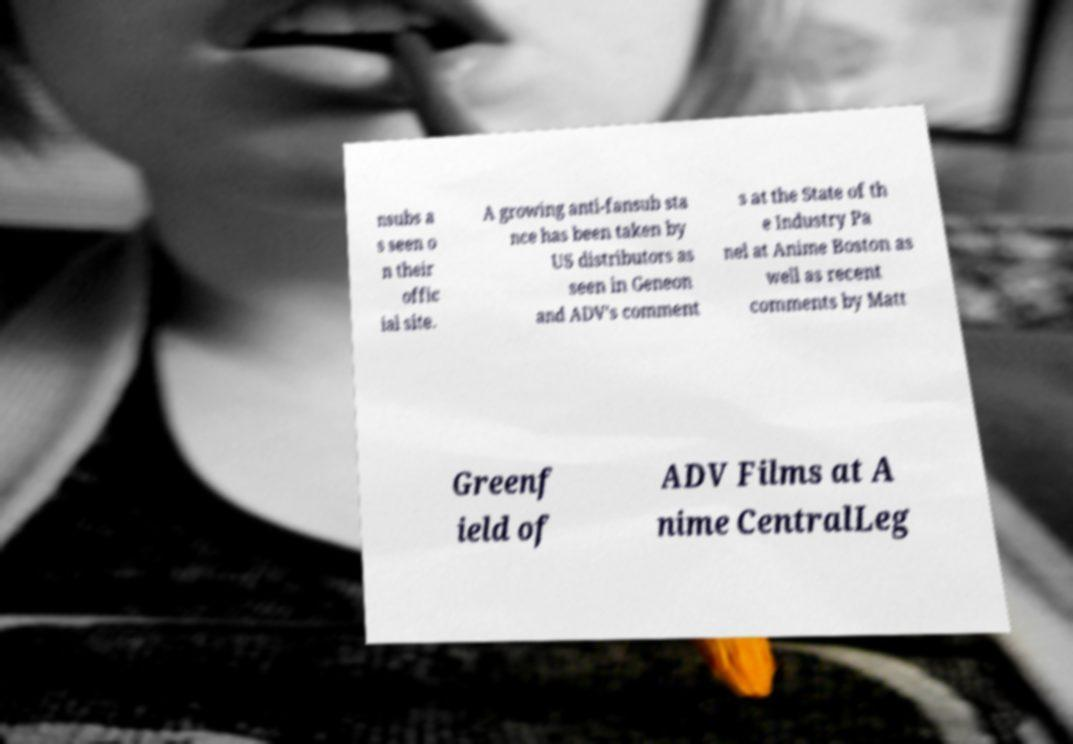Could you assist in decoding the text presented in this image and type it out clearly? nsubs a s seen o n their offic ial site. A growing anti-fansub sta nce has been taken by US distributors as seen in Geneon and ADV's comment s at the State of th e Industry Pa nel at Anime Boston as well as recent comments by Matt Greenf ield of ADV Films at A nime CentralLeg 